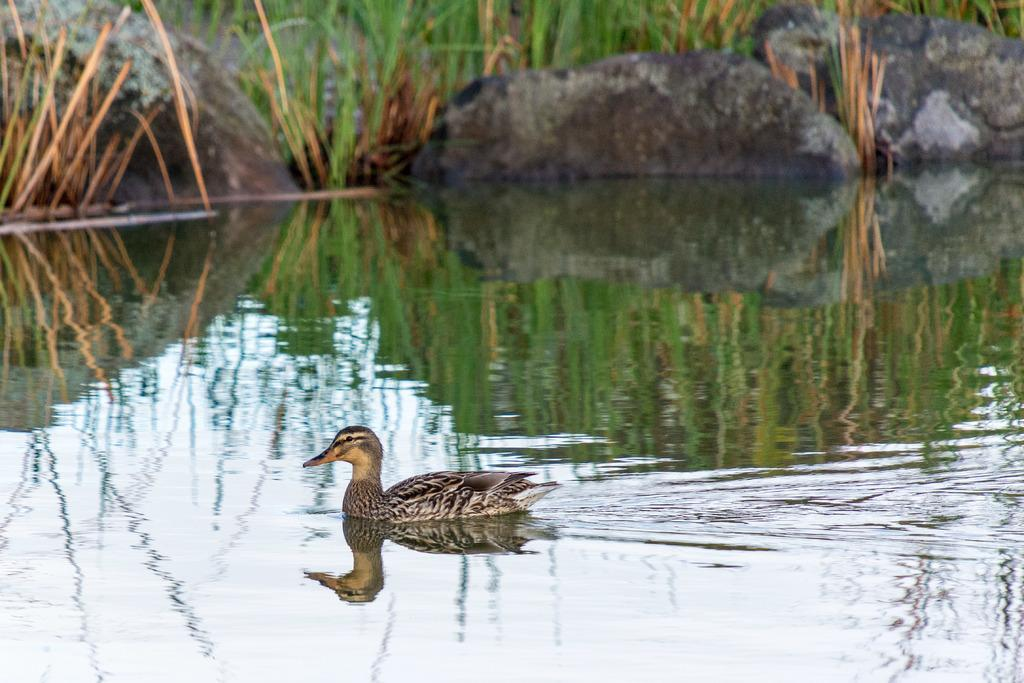What animal can be seen in the water in the image? There is a duck in the water in the image. What type of vegetation is visible in the background? There is grass in the background. What other objects can be seen in the background? There are rocks in the background. Is there a volcano visible in the image? No, there is no volcano present in the image. Can you see a minister in the image? No, there is no minister present in the image. 